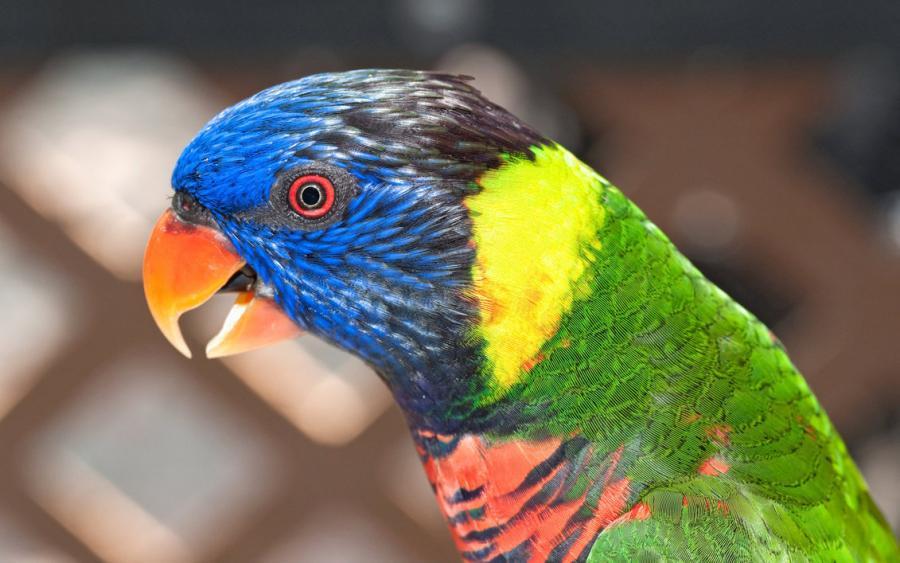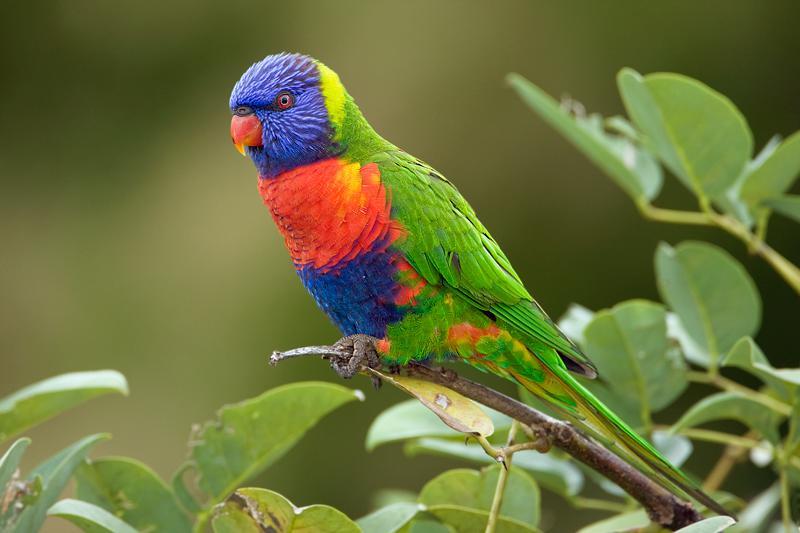The first image is the image on the left, the second image is the image on the right. Evaluate the accuracy of this statement regarding the images: "All birds are alone.". Is it true? Answer yes or no. Yes. 